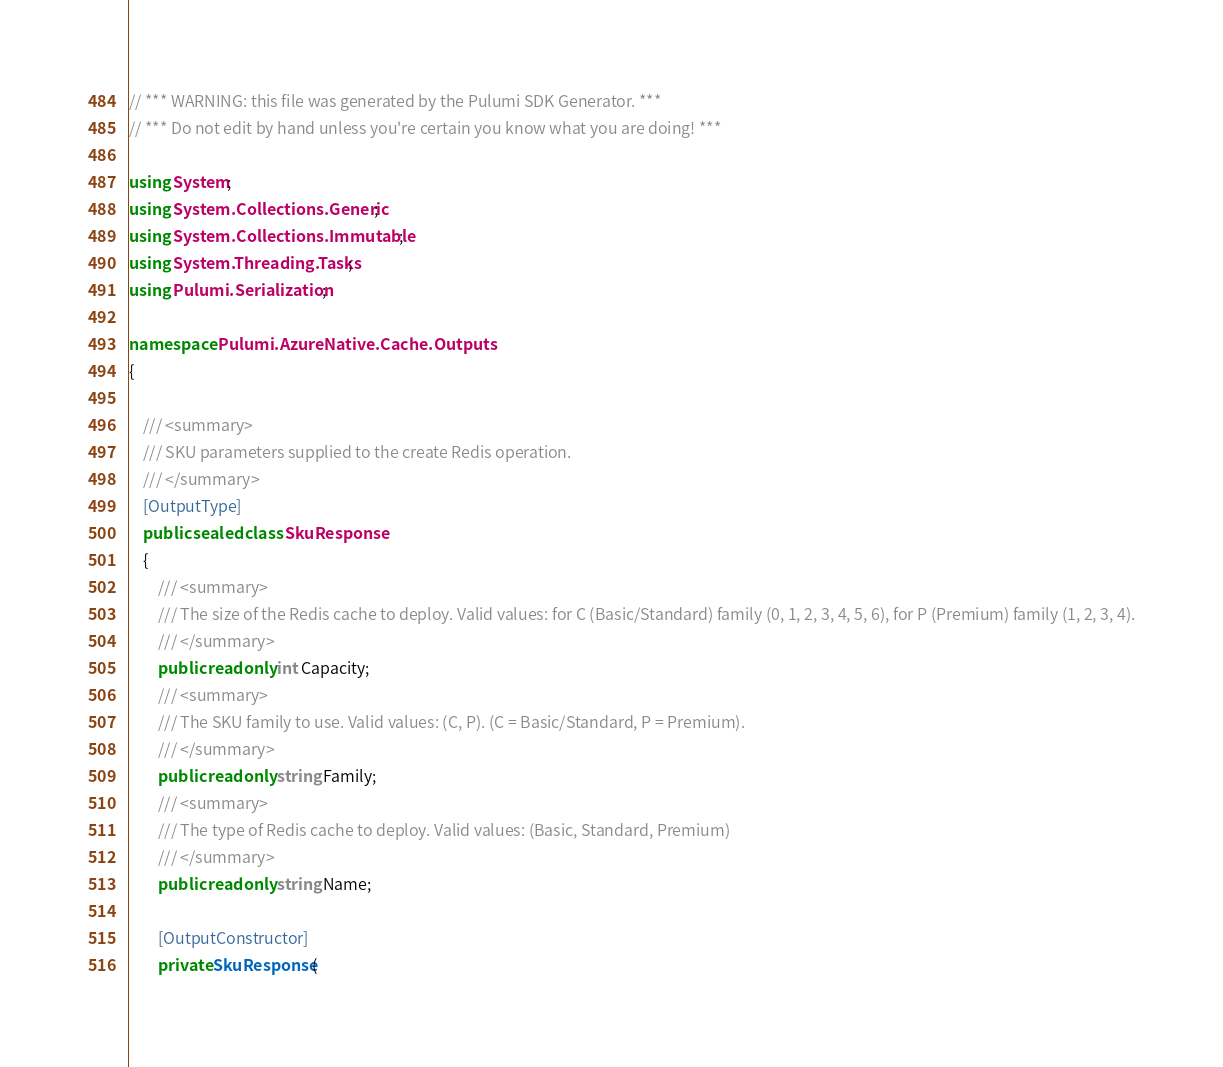Convert code to text. <code><loc_0><loc_0><loc_500><loc_500><_C#_>// *** WARNING: this file was generated by the Pulumi SDK Generator. ***
// *** Do not edit by hand unless you're certain you know what you are doing! ***

using System;
using System.Collections.Generic;
using System.Collections.Immutable;
using System.Threading.Tasks;
using Pulumi.Serialization;

namespace Pulumi.AzureNative.Cache.Outputs
{

    /// <summary>
    /// SKU parameters supplied to the create Redis operation.
    /// </summary>
    [OutputType]
    public sealed class SkuResponse
    {
        /// <summary>
        /// The size of the Redis cache to deploy. Valid values: for C (Basic/Standard) family (0, 1, 2, 3, 4, 5, 6), for P (Premium) family (1, 2, 3, 4).
        /// </summary>
        public readonly int Capacity;
        /// <summary>
        /// The SKU family to use. Valid values: (C, P). (C = Basic/Standard, P = Premium).
        /// </summary>
        public readonly string Family;
        /// <summary>
        /// The type of Redis cache to deploy. Valid values: (Basic, Standard, Premium)
        /// </summary>
        public readonly string Name;

        [OutputConstructor]
        private SkuResponse(</code> 